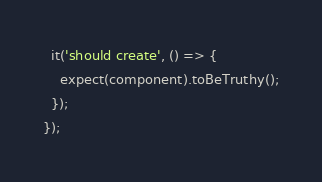<code> <loc_0><loc_0><loc_500><loc_500><_TypeScript_>
  it('should create', () => {
    expect(component).toBeTruthy();
  });
});
</code> 